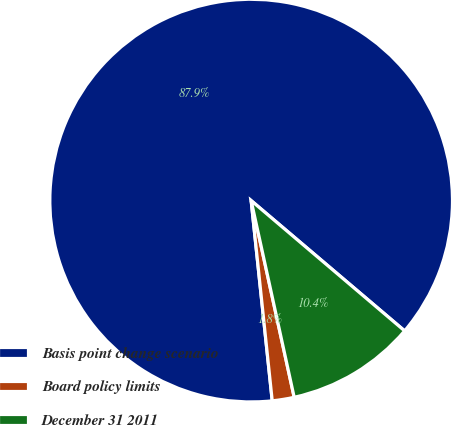Convert chart. <chart><loc_0><loc_0><loc_500><loc_500><pie_chart><fcel>Basis point change scenario<fcel>Board policy limits<fcel>December 31 2011<nl><fcel>87.87%<fcel>1.76%<fcel>10.37%<nl></chart> 